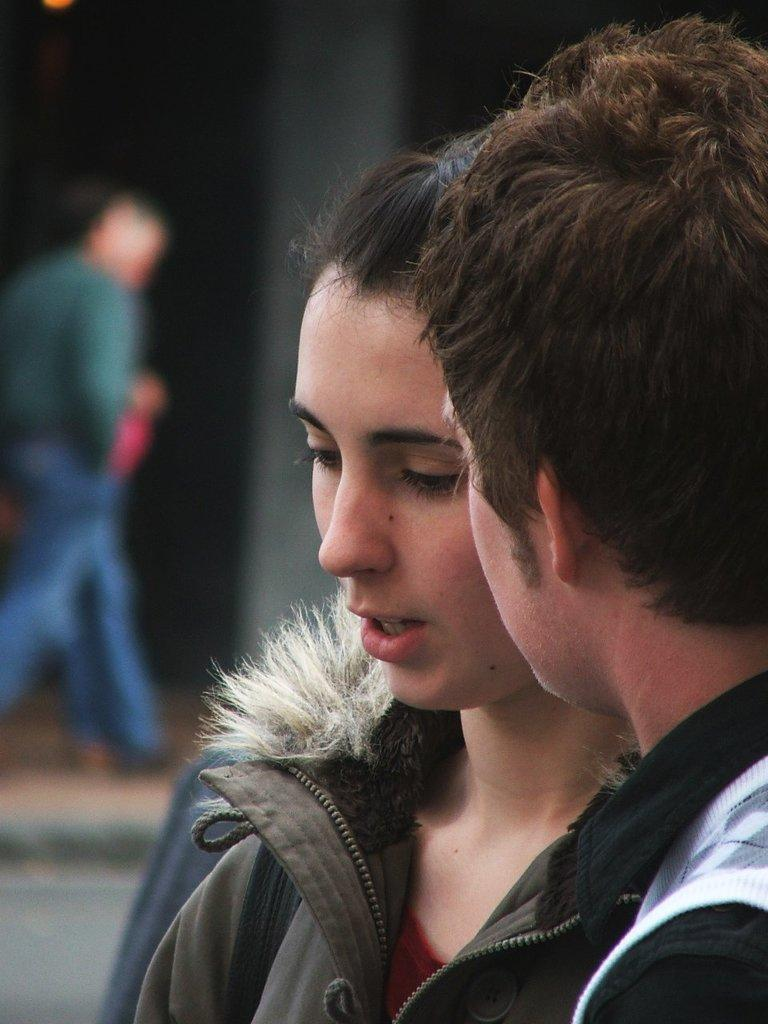How many people are in the image? There are two persons in the image. Can you describe the gender of the persons? One of the persons is a woman, and the other person is a man. What is the woman wearing in the image? The woman is wearing a jacket. Is there anyone else visible in the image? Yes, there is another person walking on the left side of the image. What type of egg is being used to make noise in the image? There is no egg or noise present in the image. 